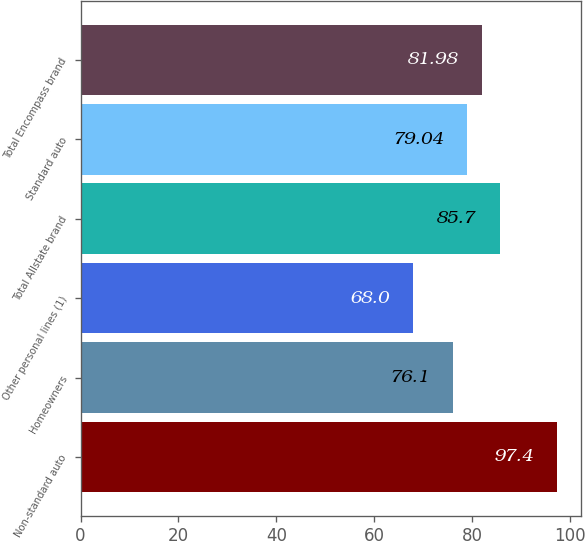Convert chart. <chart><loc_0><loc_0><loc_500><loc_500><bar_chart><fcel>Non-standard auto<fcel>Homeowners<fcel>Other personal lines (1)<fcel>Total Allstate brand<fcel>Standard auto<fcel>Total Encompass brand<nl><fcel>97.4<fcel>76.1<fcel>68<fcel>85.7<fcel>79.04<fcel>81.98<nl></chart> 